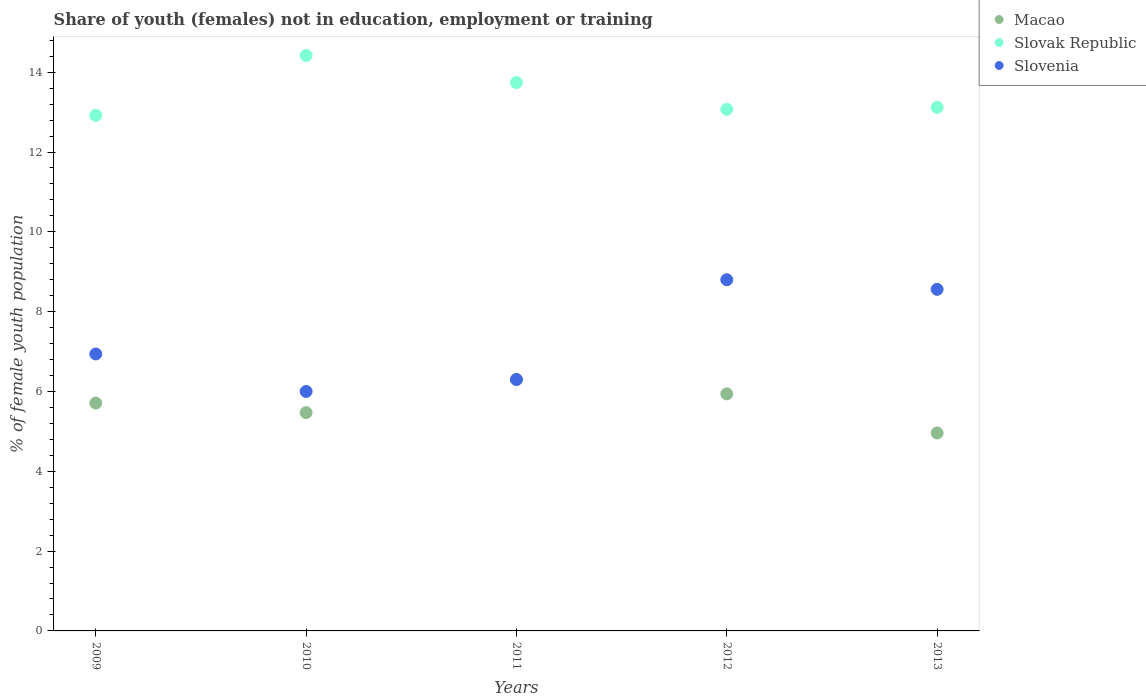What is the percentage of unemployed female population in in Slovenia in 2012?
Offer a terse response. 8.8. Across all years, what is the maximum percentage of unemployed female population in in Macao?
Keep it short and to the point. 6.3. Across all years, what is the minimum percentage of unemployed female population in in Macao?
Your answer should be compact. 4.96. In which year was the percentage of unemployed female population in in Slovak Republic maximum?
Your response must be concise. 2010. In which year was the percentage of unemployed female population in in Macao minimum?
Your answer should be compact. 2013. What is the total percentage of unemployed female population in in Macao in the graph?
Your answer should be compact. 28.38. What is the difference between the percentage of unemployed female population in in Slovak Republic in 2010 and that in 2012?
Your response must be concise. 1.35. What is the difference between the percentage of unemployed female population in in Slovak Republic in 2011 and the percentage of unemployed female population in in Slovenia in 2012?
Keep it short and to the point. 4.94. What is the average percentage of unemployed female population in in Macao per year?
Your answer should be compact. 5.68. In the year 2012, what is the difference between the percentage of unemployed female population in in Macao and percentage of unemployed female population in in Slovak Republic?
Your answer should be compact. -7.13. What is the ratio of the percentage of unemployed female population in in Slovenia in 2009 to that in 2010?
Make the answer very short. 1.16. Is the difference between the percentage of unemployed female population in in Macao in 2010 and 2012 greater than the difference between the percentage of unemployed female population in in Slovak Republic in 2010 and 2012?
Make the answer very short. No. What is the difference between the highest and the second highest percentage of unemployed female population in in Slovak Republic?
Make the answer very short. 0.68. What is the difference between the highest and the lowest percentage of unemployed female population in in Macao?
Ensure brevity in your answer.  1.34. How many dotlines are there?
Give a very brief answer. 3. What is the difference between two consecutive major ticks on the Y-axis?
Your response must be concise. 2. Are the values on the major ticks of Y-axis written in scientific E-notation?
Make the answer very short. No. Does the graph contain any zero values?
Offer a very short reply. No. Where does the legend appear in the graph?
Keep it short and to the point. Top right. What is the title of the graph?
Your answer should be very brief. Share of youth (females) not in education, employment or training. Does "Angola" appear as one of the legend labels in the graph?
Keep it short and to the point. No. What is the label or title of the Y-axis?
Offer a very short reply. % of female youth population. What is the % of female youth population of Macao in 2009?
Keep it short and to the point. 5.71. What is the % of female youth population of Slovak Republic in 2009?
Ensure brevity in your answer.  12.92. What is the % of female youth population in Slovenia in 2009?
Offer a very short reply. 6.94. What is the % of female youth population of Macao in 2010?
Your answer should be compact. 5.47. What is the % of female youth population of Slovak Republic in 2010?
Your answer should be compact. 14.42. What is the % of female youth population of Slovenia in 2010?
Your answer should be compact. 6. What is the % of female youth population in Macao in 2011?
Make the answer very short. 6.3. What is the % of female youth population of Slovak Republic in 2011?
Offer a very short reply. 13.74. What is the % of female youth population in Slovenia in 2011?
Offer a terse response. 6.3. What is the % of female youth population in Macao in 2012?
Ensure brevity in your answer.  5.94. What is the % of female youth population in Slovak Republic in 2012?
Offer a terse response. 13.07. What is the % of female youth population of Slovenia in 2012?
Your response must be concise. 8.8. What is the % of female youth population of Macao in 2013?
Provide a succinct answer. 4.96. What is the % of female youth population in Slovak Republic in 2013?
Offer a very short reply. 13.12. What is the % of female youth population of Slovenia in 2013?
Provide a succinct answer. 8.56. Across all years, what is the maximum % of female youth population in Macao?
Your answer should be compact. 6.3. Across all years, what is the maximum % of female youth population in Slovak Republic?
Keep it short and to the point. 14.42. Across all years, what is the maximum % of female youth population of Slovenia?
Keep it short and to the point. 8.8. Across all years, what is the minimum % of female youth population in Macao?
Your answer should be compact. 4.96. Across all years, what is the minimum % of female youth population in Slovak Republic?
Provide a short and direct response. 12.92. What is the total % of female youth population of Macao in the graph?
Give a very brief answer. 28.38. What is the total % of female youth population of Slovak Republic in the graph?
Offer a terse response. 67.27. What is the total % of female youth population of Slovenia in the graph?
Offer a terse response. 36.6. What is the difference between the % of female youth population of Macao in 2009 and that in 2010?
Your answer should be very brief. 0.24. What is the difference between the % of female youth population in Slovak Republic in 2009 and that in 2010?
Your answer should be compact. -1.5. What is the difference between the % of female youth population of Macao in 2009 and that in 2011?
Your answer should be compact. -0.59. What is the difference between the % of female youth population of Slovak Republic in 2009 and that in 2011?
Offer a very short reply. -0.82. What is the difference between the % of female youth population of Slovenia in 2009 and that in 2011?
Keep it short and to the point. 0.64. What is the difference between the % of female youth population of Macao in 2009 and that in 2012?
Your answer should be compact. -0.23. What is the difference between the % of female youth population of Slovenia in 2009 and that in 2012?
Your answer should be very brief. -1.86. What is the difference between the % of female youth population of Macao in 2009 and that in 2013?
Provide a short and direct response. 0.75. What is the difference between the % of female youth population of Slovenia in 2009 and that in 2013?
Your answer should be very brief. -1.62. What is the difference between the % of female youth population of Macao in 2010 and that in 2011?
Your response must be concise. -0.83. What is the difference between the % of female youth population of Slovak Republic in 2010 and that in 2011?
Keep it short and to the point. 0.68. What is the difference between the % of female youth population in Slovenia in 2010 and that in 2011?
Give a very brief answer. -0.3. What is the difference between the % of female youth population of Macao in 2010 and that in 2012?
Keep it short and to the point. -0.47. What is the difference between the % of female youth population in Slovak Republic in 2010 and that in 2012?
Give a very brief answer. 1.35. What is the difference between the % of female youth population in Slovenia in 2010 and that in 2012?
Keep it short and to the point. -2.8. What is the difference between the % of female youth population in Macao in 2010 and that in 2013?
Your response must be concise. 0.51. What is the difference between the % of female youth population of Slovak Republic in 2010 and that in 2013?
Provide a succinct answer. 1.3. What is the difference between the % of female youth population in Slovenia in 2010 and that in 2013?
Ensure brevity in your answer.  -2.56. What is the difference between the % of female youth population in Macao in 2011 and that in 2012?
Your answer should be very brief. 0.36. What is the difference between the % of female youth population in Slovak Republic in 2011 and that in 2012?
Your answer should be very brief. 0.67. What is the difference between the % of female youth population in Slovenia in 2011 and that in 2012?
Provide a short and direct response. -2.5. What is the difference between the % of female youth population of Macao in 2011 and that in 2013?
Offer a terse response. 1.34. What is the difference between the % of female youth population in Slovak Republic in 2011 and that in 2013?
Offer a terse response. 0.62. What is the difference between the % of female youth population of Slovenia in 2011 and that in 2013?
Ensure brevity in your answer.  -2.26. What is the difference between the % of female youth population of Slovak Republic in 2012 and that in 2013?
Give a very brief answer. -0.05. What is the difference between the % of female youth population in Slovenia in 2012 and that in 2013?
Your response must be concise. 0.24. What is the difference between the % of female youth population of Macao in 2009 and the % of female youth population of Slovak Republic in 2010?
Provide a succinct answer. -8.71. What is the difference between the % of female youth population of Macao in 2009 and the % of female youth population of Slovenia in 2010?
Your answer should be compact. -0.29. What is the difference between the % of female youth population in Slovak Republic in 2009 and the % of female youth population in Slovenia in 2010?
Offer a terse response. 6.92. What is the difference between the % of female youth population in Macao in 2009 and the % of female youth population in Slovak Republic in 2011?
Ensure brevity in your answer.  -8.03. What is the difference between the % of female youth population in Macao in 2009 and the % of female youth population in Slovenia in 2011?
Provide a succinct answer. -0.59. What is the difference between the % of female youth population in Slovak Republic in 2009 and the % of female youth population in Slovenia in 2011?
Ensure brevity in your answer.  6.62. What is the difference between the % of female youth population in Macao in 2009 and the % of female youth population in Slovak Republic in 2012?
Provide a short and direct response. -7.36. What is the difference between the % of female youth population in Macao in 2009 and the % of female youth population in Slovenia in 2012?
Make the answer very short. -3.09. What is the difference between the % of female youth population in Slovak Republic in 2009 and the % of female youth population in Slovenia in 2012?
Your answer should be compact. 4.12. What is the difference between the % of female youth population of Macao in 2009 and the % of female youth population of Slovak Republic in 2013?
Provide a succinct answer. -7.41. What is the difference between the % of female youth population in Macao in 2009 and the % of female youth population in Slovenia in 2013?
Ensure brevity in your answer.  -2.85. What is the difference between the % of female youth population of Slovak Republic in 2009 and the % of female youth population of Slovenia in 2013?
Provide a succinct answer. 4.36. What is the difference between the % of female youth population of Macao in 2010 and the % of female youth population of Slovak Republic in 2011?
Ensure brevity in your answer.  -8.27. What is the difference between the % of female youth population in Macao in 2010 and the % of female youth population in Slovenia in 2011?
Your response must be concise. -0.83. What is the difference between the % of female youth population in Slovak Republic in 2010 and the % of female youth population in Slovenia in 2011?
Your response must be concise. 8.12. What is the difference between the % of female youth population of Macao in 2010 and the % of female youth population of Slovak Republic in 2012?
Offer a very short reply. -7.6. What is the difference between the % of female youth population in Macao in 2010 and the % of female youth population in Slovenia in 2012?
Offer a terse response. -3.33. What is the difference between the % of female youth population in Slovak Republic in 2010 and the % of female youth population in Slovenia in 2012?
Give a very brief answer. 5.62. What is the difference between the % of female youth population in Macao in 2010 and the % of female youth population in Slovak Republic in 2013?
Provide a succinct answer. -7.65. What is the difference between the % of female youth population in Macao in 2010 and the % of female youth population in Slovenia in 2013?
Your response must be concise. -3.09. What is the difference between the % of female youth population in Slovak Republic in 2010 and the % of female youth population in Slovenia in 2013?
Your response must be concise. 5.86. What is the difference between the % of female youth population of Macao in 2011 and the % of female youth population of Slovak Republic in 2012?
Ensure brevity in your answer.  -6.77. What is the difference between the % of female youth population in Macao in 2011 and the % of female youth population in Slovenia in 2012?
Offer a terse response. -2.5. What is the difference between the % of female youth population in Slovak Republic in 2011 and the % of female youth population in Slovenia in 2012?
Give a very brief answer. 4.94. What is the difference between the % of female youth population in Macao in 2011 and the % of female youth population in Slovak Republic in 2013?
Keep it short and to the point. -6.82. What is the difference between the % of female youth population of Macao in 2011 and the % of female youth population of Slovenia in 2013?
Keep it short and to the point. -2.26. What is the difference between the % of female youth population in Slovak Republic in 2011 and the % of female youth population in Slovenia in 2013?
Offer a terse response. 5.18. What is the difference between the % of female youth population of Macao in 2012 and the % of female youth population of Slovak Republic in 2013?
Give a very brief answer. -7.18. What is the difference between the % of female youth population of Macao in 2012 and the % of female youth population of Slovenia in 2013?
Your answer should be compact. -2.62. What is the difference between the % of female youth population in Slovak Republic in 2012 and the % of female youth population in Slovenia in 2013?
Your answer should be compact. 4.51. What is the average % of female youth population of Macao per year?
Make the answer very short. 5.68. What is the average % of female youth population of Slovak Republic per year?
Provide a succinct answer. 13.45. What is the average % of female youth population of Slovenia per year?
Offer a very short reply. 7.32. In the year 2009, what is the difference between the % of female youth population of Macao and % of female youth population of Slovak Republic?
Your answer should be very brief. -7.21. In the year 2009, what is the difference between the % of female youth population in Macao and % of female youth population in Slovenia?
Your response must be concise. -1.23. In the year 2009, what is the difference between the % of female youth population of Slovak Republic and % of female youth population of Slovenia?
Keep it short and to the point. 5.98. In the year 2010, what is the difference between the % of female youth population in Macao and % of female youth population in Slovak Republic?
Offer a terse response. -8.95. In the year 2010, what is the difference between the % of female youth population of Macao and % of female youth population of Slovenia?
Make the answer very short. -0.53. In the year 2010, what is the difference between the % of female youth population of Slovak Republic and % of female youth population of Slovenia?
Provide a succinct answer. 8.42. In the year 2011, what is the difference between the % of female youth population in Macao and % of female youth population in Slovak Republic?
Offer a very short reply. -7.44. In the year 2011, what is the difference between the % of female youth population in Macao and % of female youth population in Slovenia?
Your answer should be very brief. 0. In the year 2011, what is the difference between the % of female youth population in Slovak Republic and % of female youth population in Slovenia?
Keep it short and to the point. 7.44. In the year 2012, what is the difference between the % of female youth population in Macao and % of female youth population in Slovak Republic?
Offer a terse response. -7.13. In the year 2012, what is the difference between the % of female youth population in Macao and % of female youth population in Slovenia?
Your response must be concise. -2.86. In the year 2012, what is the difference between the % of female youth population in Slovak Republic and % of female youth population in Slovenia?
Your answer should be very brief. 4.27. In the year 2013, what is the difference between the % of female youth population of Macao and % of female youth population of Slovak Republic?
Provide a succinct answer. -8.16. In the year 2013, what is the difference between the % of female youth population in Macao and % of female youth population in Slovenia?
Give a very brief answer. -3.6. In the year 2013, what is the difference between the % of female youth population of Slovak Republic and % of female youth population of Slovenia?
Make the answer very short. 4.56. What is the ratio of the % of female youth population of Macao in 2009 to that in 2010?
Ensure brevity in your answer.  1.04. What is the ratio of the % of female youth population in Slovak Republic in 2009 to that in 2010?
Your response must be concise. 0.9. What is the ratio of the % of female youth population in Slovenia in 2009 to that in 2010?
Your answer should be compact. 1.16. What is the ratio of the % of female youth population in Macao in 2009 to that in 2011?
Your response must be concise. 0.91. What is the ratio of the % of female youth population in Slovak Republic in 2009 to that in 2011?
Your answer should be very brief. 0.94. What is the ratio of the % of female youth population of Slovenia in 2009 to that in 2011?
Your answer should be compact. 1.1. What is the ratio of the % of female youth population of Macao in 2009 to that in 2012?
Provide a short and direct response. 0.96. What is the ratio of the % of female youth population in Slovenia in 2009 to that in 2012?
Provide a succinct answer. 0.79. What is the ratio of the % of female youth population in Macao in 2009 to that in 2013?
Ensure brevity in your answer.  1.15. What is the ratio of the % of female youth population in Slovenia in 2009 to that in 2013?
Provide a short and direct response. 0.81. What is the ratio of the % of female youth population of Macao in 2010 to that in 2011?
Make the answer very short. 0.87. What is the ratio of the % of female youth population in Slovak Republic in 2010 to that in 2011?
Offer a very short reply. 1.05. What is the ratio of the % of female youth population in Macao in 2010 to that in 2012?
Your answer should be compact. 0.92. What is the ratio of the % of female youth population in Slovak Republic in 2010 to that in 2012?
Your answer should be compact. 1.1. What is the ratio of the % of female youth population in Slovenia in 2010 to that in 2012?
Give a very brief answer. 0.68. What is the ratio of the % of female youth population in Macao in 2010 to that in 2013?
Provide a short and direct response. 1.1. What is the ratio of the % of female youth population of Slovak Republic in 2010 to that in 2013?
Make the answer very short. 1.1. What is the ratio of the % of female youth population in Slovenia in 2010 to that in 2013?
Your response must be concise. 0.7. What is the ratio of the % of female youth population of Macao in 2011 to that in 2012?
Give a very brief answer. 1.06. What is the ratio of the % of female youth population of Slovak Republic in 2011 to that in 2012?
Your answer should be compact. 1.05. What is the ratio of the % of female youth population in Slovenia in 2011 to that in 2012?
Provide a short and direct response. 0.72. What is the ratio of the % of female youth population of Macao in 2011 to that in 2013?
Your response must be concise. 1.27. What is the ratio of the % of female youth population of Slovak Republic in 2011 to that in 2013?
Your answer should be very brief. 1.05. What is the ratio of the % of female youth population of Slovenia in 2011 to that in 2013?
Offer a very short reply. 0.74. What is the ratio of the % of female youth population in Macao in 2012 to that in 2013?
Provide a succinct answer. 1.2. What is the ratio of the % of female youth population of Slovenia in 2012 to that in 2013?
Offer a terse response. 1.03. What is the difference between the highest and the second highest % of female youth population of Macao?
Make the answer very short. 0.36. What is the difference between the highest and the second highest % of female youth population in Slovak Republic?
Keep it short and to the point. 0.68. What is the difference between the highest and the second highest % of female youth population of Slovenia?
Make the answer very short. 0.24. What is the difference between the highest and the lowest % of female youth population in Macao?
Make the answer very short. 1.34. What is the difference between the highest and the lowest % of female youth population of Slovak Republic?
Ensure brevity in your answer.  1.5. What is the difference between the highest and the lowest % of female youth population of Slovenia?
Offer a terse response. 2.8. 